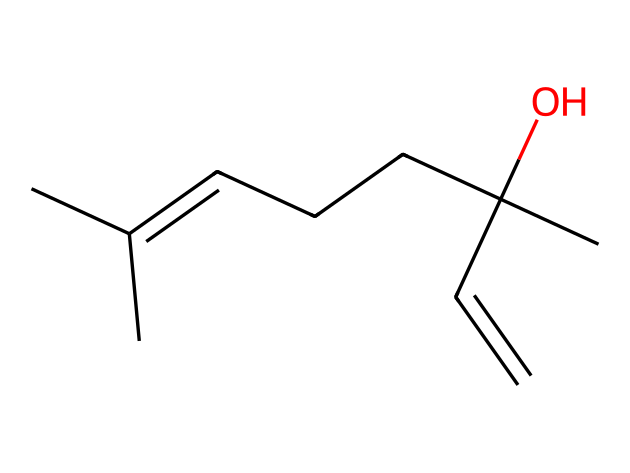What is the molecular formula of linalool? The SMILES representation provides the structural information needed to derive the molecular formula. By counting the carbon (C), hydrogen (H), and oxygen (O) atoms present in the structure, we can determine that linalool contains 10 carbons, 18 hydrogens, and 1 oxygen.
Answer: C10H18O How many double bonds are present in the structure? Analyzing the SMILES notation shows that there are two carbon-carbon double bonds indicated by the 'C=C' notation. This means that linalool has two double bonds in its structure.
Answer: 2 Is linalool a terpene? Linalool is classified as a terpene because it contains a branched hydrocarbon structure. The presence of multiple carbon atoms along with the characteristic aliphatic groups aligns with terpene classifications.
Answer: yes What functional group is indicated by the oxygen in the structure? The presence of oxygen in the SMILES indicating is connected to a carbon (C) with a hydroxyl (-OH) group suggests it has an alcohol functional group. This can be identified by recognizing the carbon bonded to the oxygen with a single bond.
Answer: alcohol What type of fragrance profile does linalool typically represent? Linalool is commonly known to provide a floral scent, characteristic of many flowers, which is why it is used in perfumes. By identifying the structural characteristics and typical uses of linalool, this allows us to classify the fragrance profile accurately.
Answer: floral 